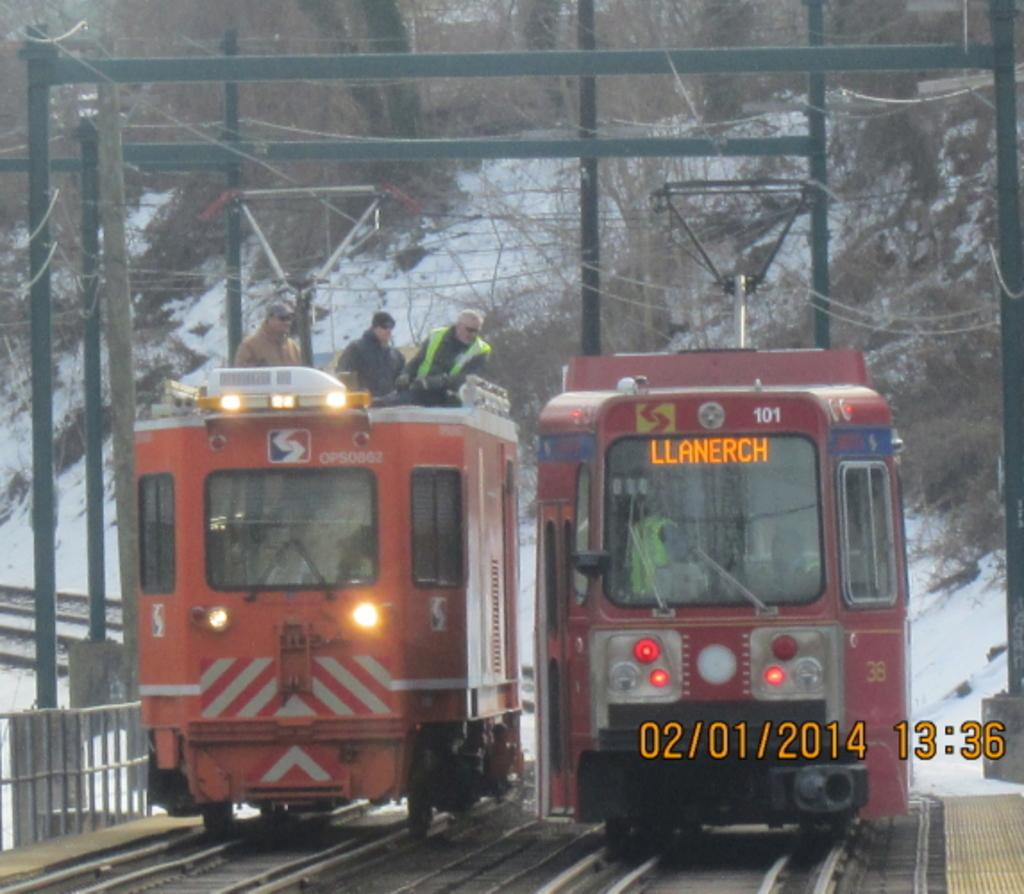<image>
Write a terse but informative summary of the picture. A red train heading towards Llanerch and a red train heading away from it. 